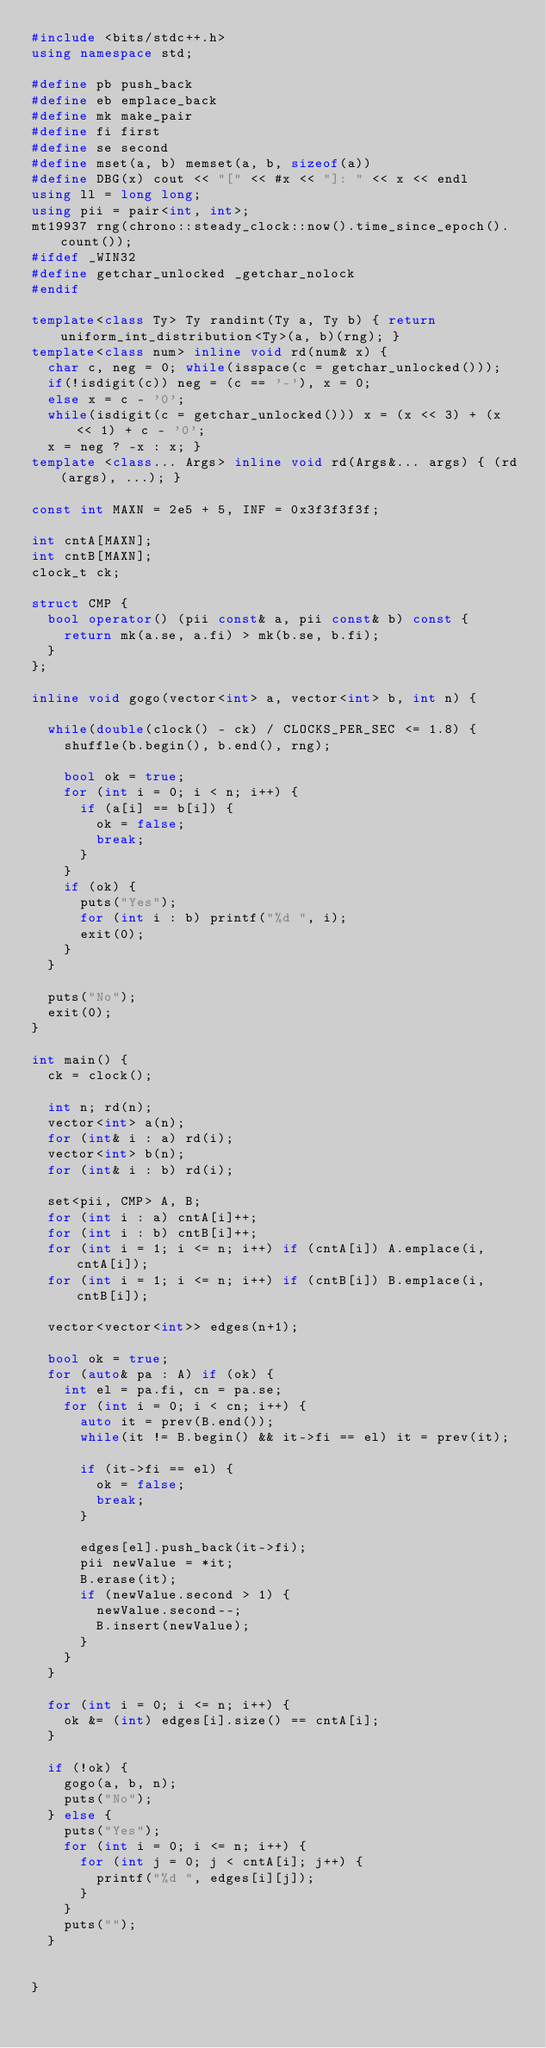Convert code to text. <code><loc_0><loc_0><loc_500><loc_500><_C++_>#include <bits/stdc++.h>
using namespace std;

#define pb push_back
#define eb emplace_back
#define mk make_pair
#define fi first
#define se second
#define mset(a, b) memset(a, b, sizeof(a))
#define DBG(x) cout << "[" << #x << "]: " << x << endl
using ll = long long;
using pii = pair<int, int>;
mt19937 rng(chrono::steady_clock::now().time_since_epoch().count());
#ifdef _WIN32
#define getchar_unlocked _getchar_nolock
#endif

template<class Ty> Ty randint(Ty a, Ty b) { return uniform_int_distribution<Ty>(a, b)(rng); }
template<class num> inline void rd(num& x) {
	char c, neg = 0; while(isspace(c = getchar_unlocked()));
	if(!isdigit(c)) neg = (c == '-'), x = 0;
	else x = c - '0';
	while(isdigit(c = getchar_unlocked())) x = (x << 3) + (x << 1) + c - '0';
	x = neg ? -x : x; }
template <class... Args> inline void rd(Args&... args) { (rd(args), ...); }

const int MAXN = 2e5 + 5, INF = 0x3f3f3f3f;

int cntA[MAXN];
int cntB[MAXN];
clock_t ck;

struct CMP {
	bool operator() (pii const& a, pii const& b) const {
		return mk(a.se, a.fi) > mk(b.se, b.fi);
	}
};

inline void gogo(vector<int> a, vector<int> b, int n) {

	while(double(clock() - ck) / CLOCKS_PER_SEC <= 1.8) {
		shuffle(b.begin(), b.end(), rng);

		bool ok = true;
		for (int i = 0; i < n; i++) {
			if (a[i] == b[i]) {
				ok = false;
				break;
			}
		}
		if (ok) {
			puts("Yes");
			for (int i : b) printf("%d ", i);
			exit(0);
		}
	}

	puts("No");
	exit(0);
}

int main() {
	ck = clock();

	int n; rd(n);
	vector<int> a(n);
	for (int& i : a) rd(i);
	vector<int> b(n);
	for (int& i : b) rd(i);

	set<pii, CMP> A, B;
	for (int i : a) cntA[i]++;
	for (int i : b) cntB[i]++;
	for (int i = 1; i <= n; i++) if (cntA[i]) A.emplace(i, cntA[i]);
	for (int i = 1; i <= n; i++) if (cntB[i]) B.emplace(i, cntB[i]);

	vector<vector<int>> edges(n+1);

	bool ok = true;
	for (auto& pa : A) if (ok) {
		int el = pa.fi, cn = pa.se;
		for (int i = 0; i < cn; i++) {
			auto it = prev(B.end());
			while(it != B.begin() && it->fi == el) it = prev(it);

			if (it->fi == el) {
				ok = false;
				break;
			}

			edges[el].push_back(it->fi);
			pii newValue = *it;
			B.erase(it);
			if (newValue.second > 1) {
				newValue.second--;
				B.insert(newValue);
			}
		}
	}

	for (int i = 0; i <= n; i++) {
		ok &= (int) edges[i].size() == cntA[i];
	}

	if (!ok) {
		gogo(a, b, n);
		puts("No");
	} else {
		puts("Yes");
		for (int i = 0; i <= n; i++) {
			for (int j = 0; j < cntA[i]; j++) {
				printf("%d ", edges[i][j]);
			}
		}
		puts("");
	}


}</code> 